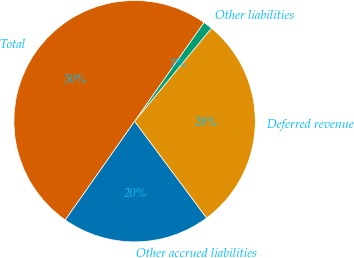<chart> <loc_0><loc_0><loc_500><loc_500><pie_chart><fcel>Other accrued liabilities<fcel>Deferred revenue<fcel>Other liabilities<fcel>Total<nl><fcel>19.94%<fcel>28.82%<fcel>1.24%<fcel>50.0%<nl></chart> 